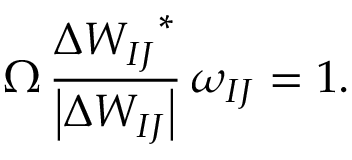<formula> <loc_0><loc_0><loc_500><loc_500>\Omega \, \frac { \Delta { W _ { I J } } ^ { * } } { \left | \Delta W _ { I J } \right | } \, \omega _ { I J } = 1 .</formula> 